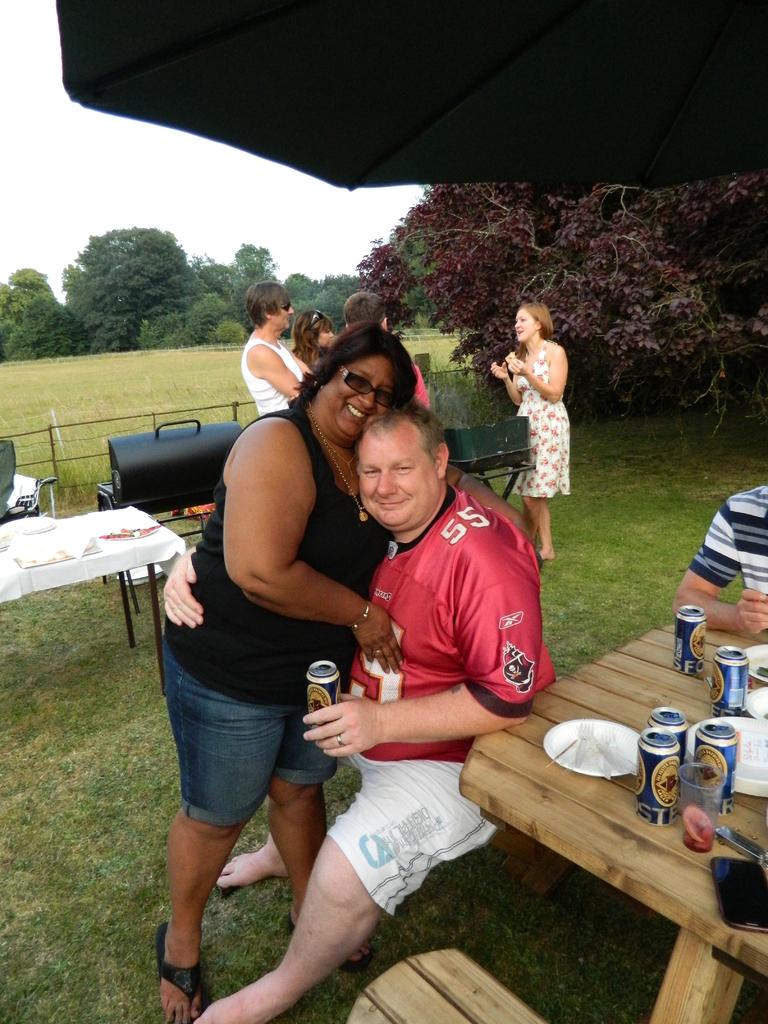What number is on his jersey?
Ensure brevity in your answer.  55. Is he wearing sunglasses?
Your answer should be compact. Answering does not require reading text in the image. 